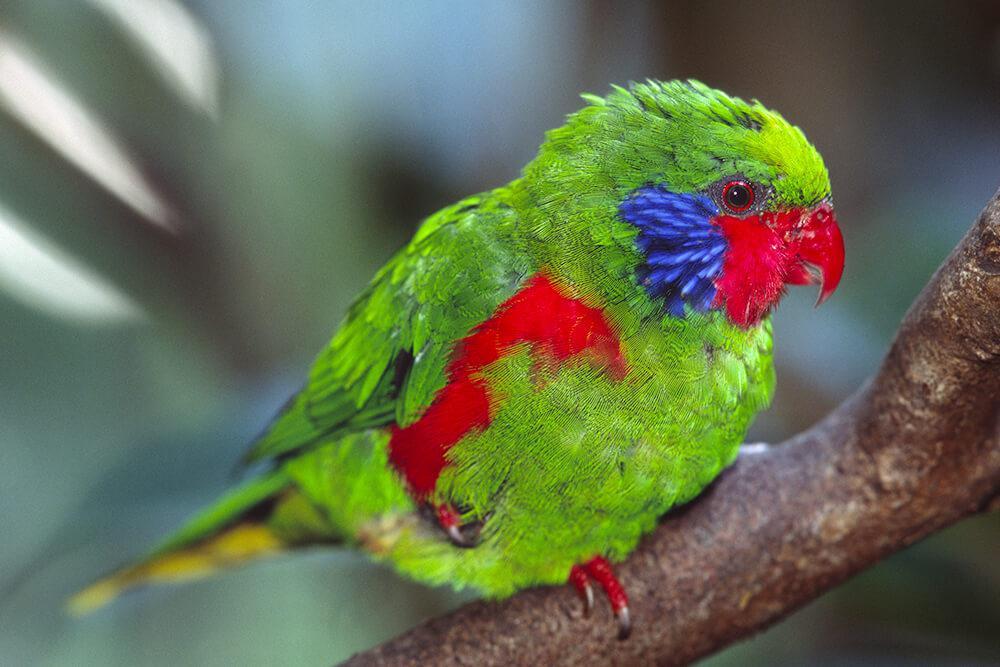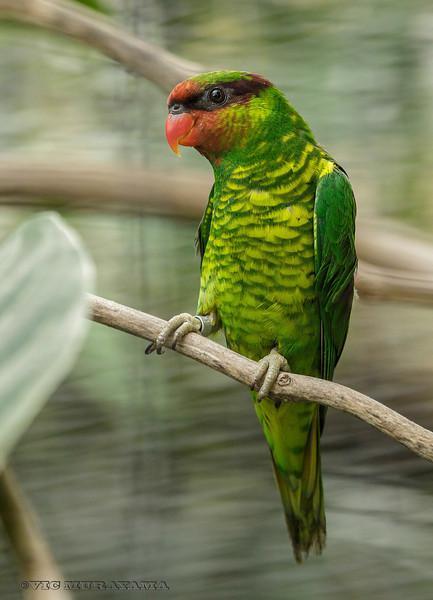The first image is the image on the left, the second image is the image on the right. Given the left and right images, does the statement "All of the images contain only one parrot." hold true? Answer yes or no. Yes. 